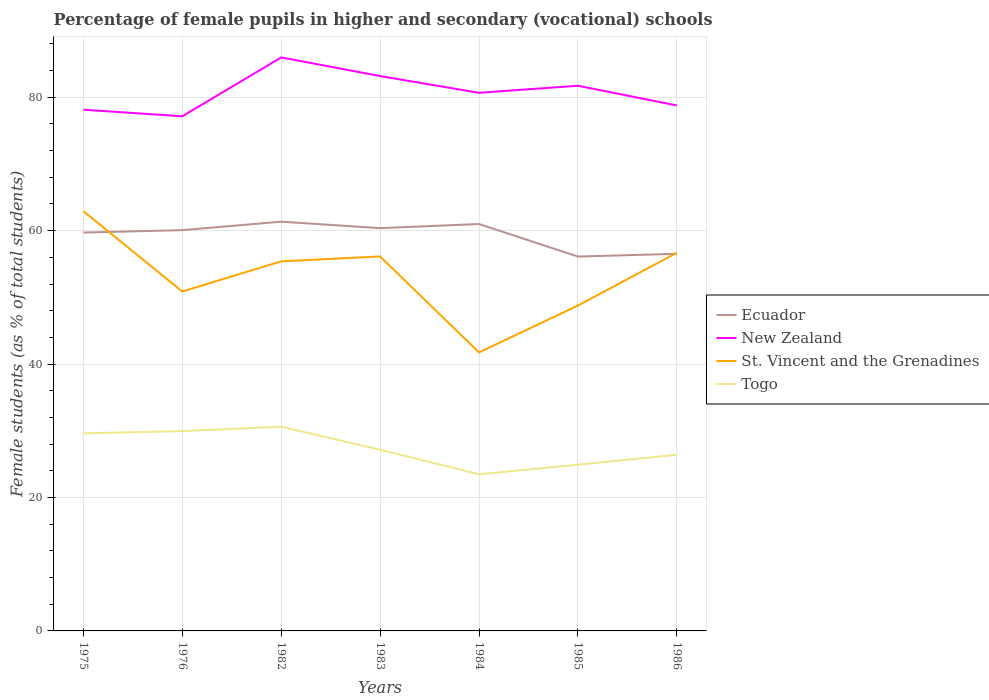Does the line corresponding to Ecuador intersect with the line corresponding to Togo?
Ensure brevity in your answer.  No. Is the number of lines equal to the number of legend labels?
Keep it short and to the point. Yes. Across all years, what is the maximum percentage of female pupils in higher and secondary schools in Togo?
Make the answer very short. 23.48. What is the total percentage of female pupils in higher and secondary schools in Ecuador in the graph?
Your answer should be compact. 5.23. What is the difference between the highest and the second highest percentage of female pupils in higher and secondary schools in Togo?
Your answer should be compact. 7.14. How many lines are there?
Your response must be concise. 4. Does the graph contain any zero values?
Ensure brevity in your answer.  No. How many legend labels are there?
Provide a succinct answer. 4. What is the title of the graph?
Provide a succinct answer. Percentage of female pupils in higher and secondary (vocational) schools. Does "Hong Kong" appear as one of the legend labels in the graph?
Keep it short and to the point. No. What is the label or title of the Y-axis?
Your answer should be compact. Female students (as % of total students). What is the Female students (as % of total students) in Ecuador in 1975?
Ensure brevity in your answer.  59.72. What is the Female students (as % of total students) in New Zealand in 1975?
Your answer should be very brief. 78.13. What is the Female students (as % of total students) of St. Vincent and the Grenadines in 1975?
Your answer should be very brief. 62.92. What is the Female students (as % of total students) of Togo in 1975?
Give a very brief answer. 29.62. What is the Female students (as % of total students) of Ecuador in 1976?
Ensure brevity in your answer.  60.08. What is the Female students (as % of total students) in New Zealand in 1976?
Ensure brevity in your answer.  77.15. What is the Female students (as % of total students) of St. Vincent and the Grenadines in 1976?
Your answer should be compact. 50.88. What is the Female students (as % of total students) of Togo in 1976?
Make the answer very short. 29.95. What is the Female students (as % of total students) of Ecuador in 1982?
Offer a very short reply. 61.35. What is the Female students (as % of total students) in New Zealand in 1982?
Your answer should be compact. 85.97. What is the Female students (as % of total students) in St. Vincent and the Grenadines in 1982?
Keep it short and to the point. 55.4. What is the Female students (as % of total students) of Togo in 1982?
Your response must be concise. 30.61. What is the Female students (as % of total students) of Ecuador in 1983?
Provide a succinct answer. 60.38. What is the Female students (as % of total students) in New Zealand in 1983?
Keep it short and to the point. 83.17. What is the Female students (as % of total students) in St. Vincent and the Grenadines in 1983?
Ensure brevity in your answer.  56.13. What is the Female students (as % of total students) in Togo in 1983?
Your answer should be very brief. 27.16. What is the Female students (as % of total students) in Ecuador in 1984?
Keep it short and to the point. 61. What is the Female students (as % of total students) of New Zealand in 1984?
Provide a short and direct response. 80.66. What is the Female students (as % of total students) in St. Vincent and the Grenadines in 1984?
Provide a short and direct response. 41.75. What is the Female students (as % of total students) in Togo in 1984?
Provide a short and direct response. 23.48. What is the Female students (as % of total students) in Ecuador in 1985?
Your response must be concise. 56.12. What is the Female students (as % of total students) in New Zealand in 1985?
Offer a very short reply. 81.72. What is the Female students (as % of total students) in St. Vincent and the Grenadines in 1985?
Offer a terse response. 48.77. What is the Female students (as % of total students) of Togo in 1985?
Your response must be concise. 24.92. What is the Female students (as % of total students) in Ecuador in 1986?
Provide a succinct answer. 56.53. What is the Female students (as % of total students) of New Zealand in 1986?
Your answer should be compact. 78.77. What is the Female students (as % of total students) in St. Vincent and the Grenadines in 1986?
Provide a short and direct response. 56.68. What is the Female students (as % of total students) of Togo in 1986?
Make the answer very short. 26.4. Across all years, what is the maximum Female students (as % of total students) in Ecuador?
Keep it short and to the point. 61.35. Across all years, what is the maximum Female students (as % of total students) of New Zealand?
Provide a short and direct response. 85.97. Across all years, what is the maximum Female students (as % of total students) in St. Vincent and the Grenadines?
Give a very brief answer. 62.92. Across all years, what is the maximum Female students (as % of total students) in Togo?
Ensure brevity in your answer.  30.61. Across all years, what is the minimum Female students (as % of total students) in Ecuador?
Your answer should be very brief. 56.12. Across all years, what is the minimum Female students (as % of total students) of New Zealand?
Make the answer very short. 77.15. Across all years, what is the minimum Female students (as % of total students) of St. Vincent and the Grenadines?
Offer a terse response. 41.75. Across all years, what is the minimum Female students (as % of total students) in Togo?
Ensure brevity in your answer.  23.48. What is the total Female students (as % of total students) in Ecuador in the graph?
Your answer should be very brief. 415.16. What is the total Female students (as % of total students) in New Zealand in the graph?
Your answer should be very brief. 565.57. What is the total Female students (as % of total students) of St. Vincent and the Grenadines in the graph?
Offer a terse response. 372.53. What is the total Female students (as % of total students) in Togo in the graph?
Make the answer very short. 192.14. What is the difference between the Female students (as % of total students) of Ecuador in 1975 and that in 1976?
Provide a short and direct response. -0.36. What is the difference between the Female students (as % of total students) in New Zealand in 1975 and that in 1976?
Offer a very short reply. 0.99. What is the difference between the Female students (as % of total students) of St. Vincent and the Grenadines in 1975 and that in 1976?
Provide a succinct answer. 12.04. What is the difference between the Female students (as % of total students) of Togo in 1975 and that in 1976?
Keep it short and to the point. -0.33. What is the difference between the Female students (as % of total students) in Ecuador in 1975 and that in 1982?
Provide a short and direct response. -1.63. What is the difference between the Female students (as % of total students) of New Zealand in 1975 and that in 1982?
Provide a succinct answer. -7.84. What is the difference between the Female students (as % of total students) of St. Vincent and the Grenadines in 1975 and that in 1982?
Your answer should be very brief. 7.52. What is the difference between the Female students (as % of total students) of Togo in 1975 and that in 1982?
Your answer should be compact. -1. What is the difference between the Female students (as % of total students) of Ecuador in 1975 and that in 1983?
Your answer should be very brief. -0.66. What is the difference between the Female students (as % of total students) in New Zealand in 1975 and that in 1983?
Provide a short and direct response. -5.04. What is the difference between the Female students (as % of total students) of St. Vincent and the Grenadines in 1975 and that in 1983?
Your answer should be very brief. 6.78. What is the difference between the Female students (as % of total students) in Togo in 1975 and that in 1983?
Your answer should be compact. 2.46. What is the difference between the Female students (as % of total students) in Ecuador in 1975 and that in 1984?
Your answer should be very brief. -1.28. What is the difference between the Female students (as % of total students) in New Zealand in 1975 and that in 1984?
Offer a very short reply. -2.53. What is the difference between the Female students (as % of total students) in St. Vincent and the Grenadines in 1975 and that in 1984?
Your answer should be compact. 21.17. What is the difference between the Female students (as % of total students) of Togo in 1975 and that in 1984?
Your answer should be compact. 6.14. What is the difference between the Female students (as % of total students) in Ecuador in 1975 and that in 1985?
Your answer should be very brief. 3.6. What is the difference between the Female students (as % of total students) of New Zealand in 1975 and that in 1985?
Give a very brief answer. -3.59. What is the difference between the Female students (as % of total students) of St. Vincent and the Grenadines in 1975 and that in 1985?
Provide a succinct answer. 14.15. What is the difference between the Female students (as % of total students) in Togo in 1975 and that in 1985?
Give a very brief answer. 4.7. What is the difference between the Female students (as % of total students) of Ecuador in 1975 and that in 1986?
Ensure brevity in your answer.  3.19. What is the difference between the Female students (as % of total students) in New Zealand in 1975 and that in 1986?
Provide a short and direct response. -0.64. What is the difference between the Female students (as % of total students) of St. Vincent and the Grenadines in 1975 and that in 1986?
Give a very brief answer. 6.24. What is the difference between the Female students (as % of total students) in Togo in 1975 and that in 1986?
Provide a succinct answer. 3.22. What is the difference between the Female students (as % of total students) of Ecuador in 1976 and that in 1982?
Your answer should be compact. -1.27. What is the difference between the Female students (as % of total students) in New Zealand in 1976 and that in 1982?
Give a very brief answer. -8.82. What is the difference between the Female students (as % of total students) of St. Vincent and the Grenadines in 1976 and that in 1982?
Your response must be concise. -4.52. What is the difference between the Female students (as % of total students) of Togo in 1976 and that in 1982?
Make the answer very short. -0.66. What is the difference between the Female students (as % of total students) of Ecuador in 1976 and that in 1983?
Offer a very short reply. -0.3. What is the difference between the Female students (as % of total students) of New Zealand in 1976 and that in 1983?
Offer a terse response. -6.03. What is the difference between the Female students (as % of total students) of St. Vincent and the Grenadines in 1976 and that in 1983?
Keep it short and to the point. -5.26. What is the difference between the Female students (as % of total students) in Togo in 1976 and that in 1983?
Provide a short and direct response. 2.79. What is the difference between the Female students (as % of total students) of Ecuador in 1976 and that in 1984?
Your response must be concise. -0.92. What is the difference between the Female students (as % of total students) of New Zealand in 1976 and that in 1984?
Ensure brevity in your answer.  -3.52. What is the difference between the Female students (as % of total students) in St. Vincent and the Grenadines in 1976 and that in 1984?
Provide a short and direct response. 9.13. What is the difference between the Female students (as % of total students) of Togo in 1976 and that in 1984?
Provide a short and direct response. 6.47. What is the difference between the Female students (as % of total students) of Ecuador in 1976 and that in 1985?
Your response must be concise. 3.96. What is the difference between the Female students (as % of total students) of New Zealand in 1976 and that in 1985?
Offer a terse response. -4.58. What is the difference between the Female students (as % of total students) of St. Vincent and the Grenadines in 1976 and that in 1985?
Make the answer very short. 2.11. What is the difference between the Female students (as % of total students) of Togo in 1976 and that in 1985?
Ensure brevity in your answer.  5.03. What is the difference between the Female students (as % of total students) of Ecuador in 1976 and that in 1986?
Ensure brevity in your answer.  3.55. What is the difference between the Female students (as % of total students) in New Zealand in 1976 and that in 1986?
Your response must be concise. -1.62. What is the difference between the Female students (as % of total students) of St. Vincent and the Grenadines in 1976 and that in 1986?
Ensure brevity in your answer.  -5.8. What is the difference between the Female students (as % of total students) in Togo in 1976 and that in 1986?
Your answer should be very brief. 3.55. What is the difference between the Female students (as % of total students) in Ecuador in 1982 and that in 1983?
Give a very brief answer. 0.97. What is the difference between the Female students (as % of total students) in New Zealand in 1982 and that in 1983?
Ensure brevity in your answer.  2.8. What is the difference between the Female students (as % of total students) of St. Vincent and the Grenadines in 1982 and that in 1983?
Your answer should be compact. -0.73. What is the difference between the Female students (as % of total students) in Togo in 1982 and that in 1983?
Make the answer very short. 3.46. What is the difference between the Female students (as % of total students) in Ecuador in 1982 and that in 1984?
Offer a terse response. 0.35. What is the difference between the Female students (as % of total students) of New Zealand in 1982 and that in 1984?
Your response must be concise. 5.31. What is the difference between the Female students (as % of total students) of St. Vincent and the Grenadines in 1982 and that in 1984?
Your answer should be very brief. 13.65. What is the difference between the Female students (as % of total students) in Togo in 1982 and that in 1984?
Your response must be concise. 7.14. What is the difference between the Female students (as % of total students) of Ecuador in 1982 and that in 1985?
Ensure brevity in your answer.  5.23. What is the difference between the Female students (as % of total students) in New Zealand in 1982 and that in 1985?
Make the answer very short. 4.25. What is the difference between the Female students (as % of total students) of St. Vincent and the Grenadines in 1982 and that in 1985?
Provide a short and direct response. 6.63. What is the difference between the Female students (as % of total students) in Togo in 1982 and that in 1985?
Offer a terse response. 5.7. What is the difference between the Female students (as % of total students) of Ecuador in 1982 and that in 1986?
Keep it short and to the point. 4.82. What is the difference between the Female students (as % of total students) in New Zealand in 1982 and that in 1986?
Offer a very short reply. 7.2. What is the difference between the Female students (as % of total students) in St. Vincent and the Grenadines in 1982 and that in 1986?
Ensure brevity in your answer.  -1.28. What is the difference between the Female students (as % of total students) of Togo in 1982 and that in 1986?
Give a very brief answer. 4.21. What is the difference between the Female students (as % of total students) of Ecuador in 1983 and that in 1984?
Keep it short and to the point. -0.62. What is the difference between the Female students (as % of total students) of New Zealand in 1983 and that in 1984?
Offer a very short reply. 2.51. What is the difference between the Female students (as % of total students) of St. Vincent and the Grenadines in 1983 and that in 1984?
Your answer should be compact. 14.39. What is the difference between the Female students (as % of total students) of Togo in 1983 and that in 1984?
Keep it short and to the point. 3.68. What is the difference between the Female students (as % of total students) in Ecuador in 1983 and that in 1985?
Offer a terse response. 4.26. What is the difference between the Female students (as % of total students) of New Zealand in 1983 and that in 1985?
Provide a short and direct response. 1.45. What is the difference between the Female students (as % of total students) of St. Vincent and the Grenadines in 1983 and that in 1985?
Your answer should be very brief. 7.36. What is the difference between the Female students (as % of total students) in Togo in 1983 and that in 1985?
Your response must be concise. 2.24. What is the difference between the Female students (as % of total students) of Ecuador in 1983 and that in 1986?
Your response must be concise. 3.85. What is the difference between the Female students (as % of total students) in New Zealand in 1983 and that in 1986?
Give a very brief answer. 4.4. What is the difference between the Female students (as % of total students) of St. Vincent and the Grenadines in 1983 and that in 1986?
Your answer should be very brief. -0.55. What is the difference between the Female students (as % of total students) in Togo in 1983 and that in 1986?
Offer a terse response. 0.76. What is the difference between the Female students (as % of total students) of Ecuador in 1984 and that in 1985?
Make the answer very short. 4.88. What is the difference between the Female students (as % of total students) in New Zealand in 1984 and that in 1985?
Your answer should be very brief. -1.06. What is the difference between the Female students (as % of total students) of St. Vincent and the Grenadines in 1984 and that in 1985?
Keep it short and to the point. -7.02. What is the difference between the Female students (as % of total students) in Togo in 1984 and that in 1985?
Provide a succinct answer. -1.44. What is the difference between the Female students (as % of total students) in Ecuador in 1984 and that in 1986?
Your answer should be very brief. 4.47. What is the difference between the Female students (as % of total students) of New Zealand in 1984 and that in 1986?
Give a very brief answer. 1.89. What is the difference between the Female students (as % of total students) of St. Vincent and the Grenadines in 1984 and that in 1986?
Your answer should be compact. -14.93. What is the difference between the Female students (as % of total students) in Togo in 1984 and that in 1986?
Provide a short and direct response. -2.92. What is the difference between the Female students (as % of total students) in Ecuador in 1985 and that in 1986?
Keep it short and to the point. -0.41. What is the difference between the Female students (as % of total students) in New Zealand in 1985 and that in 1986?
Offer a very short reply. 2.95. What is the difference between the Female students (as % of total students) of St. Vincent and the Grenadines in 1985 and that in 1986?
Provide a short and direct response. -7.91. What is the difference between the Female students (as % of total students) of Togo in 1985 and that in 1986?
Make the answer very short. -1.48. What is the difference between the Female students (as % of total students) of Ecuador in 1975 and the Female students (as % of total students) of New Zealand in 1976?
Provide a short and direct response. -17.43. What is the difference between the Female students (as % of total students) in Ecuador in 1975 and the Female students (as % of total students) in St. Vincent and the Grenadines in 1976?
Your answer should be compact. 8.84. What is the difference between the Female students (as % of total students) of Ecuador in 1975 and the Female students (as % of total students) of Togo in 1976?
Provide a short and direct response. 29.77. What is the difference between the Female students (as % of total students) of New Zealand in 1975 and the Female students (as % of total students) of St. Vincent and the Grenadines in 1976?
Your answer should be very brief. 27.25. What is the difference between the Female students (as % of total students) of New Zealand in 1975 and the Female students (as % of total students) of Togo in 1976?
Your answer should be very brief. 48.18. What is the difference between the Female students (as % of total students) of St. Vincent and the Grenadines in 1975 and the Female students (as % of total students) of Togo in 1976?
Keep it short and to the point. 32.97. What is the difference between the Female students (as % of total students) in Ecuador in 1975 and the Female students (as % of total students) in New Zealand in 1982?
Give a very brief answer. -26.25. What is the difference between the Female students (as % of total students) of Ecuador in 1975 and the Female students (as % of total students) of St. Vincent and the Grenadines in 1982?
Your answer should be compact. 4.31. What is the difference between the Female students (as % of total students) in Ecuador in 1975 and the Female students (as % of total students) in Togo in 1982?
Give a very brief answer. 29.1. What is the difference between the Female students (as % of total students) in New Zealand in 1975 and the Female students (as % of total students) in St. Vincent and the Grenadines in 1982?
Your answer should be very brief. 22.73. What is the difference between the Female students (as % of total students) of New Zealand in 1975 and the Female students (as % of total students) of Togo in 1982?
Your response must be concise. 47.52. What is the difference between the Female students (as % of total students) of St. Vincent and the Grenadines in 1975 and the Female students (as % of total students) of Togo in 1982?
Keep it short and to the point. 32.3. What is the difference between the Female students (as % of total students) in Ecuador in 1975 and the Female students (as % of total students) in New Zealand in 1983?
Offer a very short reply. -23.46. What is the difference between the Female students (as % of total students) in Ecuador in 1975 and the Female students (as % of total students) in St. Vincent and the Grenadines in 1983?
Your response must be concise. 3.58. What is the difference between the Female students (as % of total students) of Ecuador in 1975 and the Female students (as % of total students) of Togo in 1983?
Your answer should be very brief. 32.56. What is the difference between the Female students (as % of total students) in New Zealand in 1975 and the Female students (as % of total students) in St. Vincent and the Grenadines in 1983?
Your response must be concise. 22. What is the difference between the Female students (as % of total students) in New Zealand in 1975 and the Female students (as % of total students) in Togo in 1983?
Your answer should be very brief. 50.97. What is the difference between the Female students (as % of total students) of St. Vincent and the Grenadines in 1975 and the Female students (as % of total students) of Togo in 1983?
Keep it short and to the point. 35.76. What is the difference between the Female students (as % of total students) of Ecuador in 1975 and the Female students (as % of total students) of New Zealand in 1984?
Your answer should be compact. -20.95. What is the difference between the Female students (as % of total students) of Ecuador in 1975 and the Female students (as % of total students) of St. Vincent and the Grenadines in 1984?
Keep it short and to the point. 17.97. What is the difference between the Female students (as % of total students) of Ecuador in 1975 and the Female students (as % of total students) of Togo in 1984?
Provide a succinct answer. 36.24. What is the difference between the Female students (as % of total students) of New Zealand in 1975 and the Female students (as % of total students) of St. Vincent and the Grenadines in 1984?
Keep it short and to the point. 36.38. What is the difference between the Female students (as % of total students) of New Zealand in 1975 and the Female students (as % of total students) of Togo in 1984?
Offer a terse response. 54.65. What is the difference between the Female students (as % of total students) in St. Vincent and the Grenadines in 1975 and the Female students (as % of total students) in Togo in 1984?
Give a very brief answer. 39.44. What is the difference between the Female students (as % of total students) of Ecuador in 1975 and the Female students (as % of total students) of New Zealand in 1985?
Make the answer very short. -22.01. What is the difference between the Female students (as % of total students) of Ecuador in 1975 and the Female students (as % of total students) of St. Vincent and the Grenadines in 1985?
Your answer should be very brief. 10.94. What is the difference between the Female students (as % of total students) of Ecuador in 1975 and the Female students (as % of total students) of Togo in 1985?
Ensure brevity in your answer.  34.8. What is the difference between the Female students (as % of total students) in New Zealand in 1975 and the Female students (as % of total students) in St. Vincent and the Grenadines in 1985?
Your answer should be very brief. 29.36. What is the difference between the Female students (as % of total students) of New Zealand in 1975 and the Female students (as % of total students) of Togo in 1985?
Ensure brevity in your answer.  53.21. What is the difference between the Female students (as % of total students) of St. Vincent and the Grenadines in 1975 and the Female students (as % of total students) of Togo in 1985?
Your answer should be compact. 38. What is the difference between the Female students (as % of total students) in Ecuador in 1975 and the Female students (as % of total students) in New Zealand in 1986?
Provide a succinct answer. -19.05. What is the difference between the Female students (as % of total students) of Ecuador in 1975 and the Female students (as % of total students) of St. Vincent and the Grenadines in 1986?
Your response must be concise. 3.04. What is the difference between the Female students (as % of total students) of Ecuador in 1975 and the Female students (as % of total students) of Togo in 1986?
Your answer should be very brief. 33.31. What is the difference between the Female students (as % of total students) in New Zealand in 1975 and the Female students (as % of total students) in St. Vincent and the Grenadines in 1986?
Keep it short and to the point. 21.45. What is the difference between the Female students (as % of total students) of New Zealand in 1975 and the Female students (as % of total students) of Togo in 1986?
Your response must be concise. 51.73. What is the difference between the Female students (as % of total students) of St. Vincent and the Grenadines in 1975 and the Female students (as % of total students) of Togo in 1986?
Make the answer very short. 36.52. What is the difference between the Female students (as % of total students) of Ecuador in 1976 and the Female students (as % of total students) of New Zealand in 1982?
Provide a short and direct response. -25.89. What is the difference between the Female students (as % of total students) of Ecuador in 1976 and the Female students (as % of total students) of St. Vincent and the Grenadines in 1982?
Provide a short and direct response. 4.67. What is the difference between the Female students (as % of total students) of Ecuador in 1976 and the Female students (as % of total students) of Togo in 1982?
Provide a succinct answer. 29.46. What is the difference between the Female students (as % of total students) in New Zealand in 1976 and the Female students (as % of total students) in St. Vincent and the Grenadines in 1982?
Your answer should be very brief. 21.75. What is the difference between the Female students (as % of total students) in New Zealand in 1976 and the Female students (as % of total students) in Togo in 1982?
Your answer should be compact. 46.53. What is the difference between the Female students (as % of total students) in St. Vincent and the Grenadines in 1976 and the Female students (as % of total students) in Togo in 1982?
Your answer should be compact. 20.26. What is the difference between the Female students (as % of total students) of Ecuador in 1976 and the Female students (as % of total students) of New Zealand in 1983?
Your answer should be very brief. -23.1. What is the difference between the Female students (as % of total students) of Ecuador in 1976 and the Female students (as % of total students) of St. Vincent and the Grenadines in 1983?
Your answer should be compact. 3.94. What is the difference between the Female students (as % of total students) of Ecuador in 1976 and the Female students (as % of total students) of Togo in 1983?
Offer a terse response. 32.92. What is the difference between the Female students (as % of total students) in New Zealand in 1976 and the Female students (as % of total students) in St. Vincent and the Grenadines in 1983?
Make the answer very short. 21.01. What is the difference between the Female students (as % of total students) of New Zealand in 1976 and the Female students (as % of total students) of Togo in 1983?
Your response must be concise. 49.99. What is the difference between the Female students (as % of total students) in St. Vincent and the Grenadines in 1976 and the Female students (as % of total students) in Togo in 1983?
Offer a terse response. 23.72. What is the difference between the Female students (as % of total students) of Ecuador in 1976 and the Female students (as % of total students) of New Zealand in 1984?
Provide a short and direct response. -20.59. What is the difference between the Female students (as % of total students) in Ecuador in 1976 and the Female students (as % of total students) in St. Vincent and the Grenadines in 1984?
Offer a terse response. 18.33. What is the difference between the Female students (as % of total students) in Ecuador in 1976 and the Female students (as % of total students) in Togo in 1984?
Your answer should be very brief. 36.6. What is the difference between the Female students (as % of total students) in New Zealand in 1976 and the Female students (as % of total students) in St. Vincent and the Grenadines in 1984?
Your response must be concise. 35.4. What is the difference between the Female students (as % of total students) of New Zealand in 1976 and the Female students (as % of total students) of Togo in 1984?
Your answer should be very brief. 53.67. What is the difference between the Female students (as % of total students) of St. Vincent and the Grenadines in 1976 and the Female students (as % of total students) of Togo in 1984?
Offer a terse response. 27.4. What is the difference between the Female students (as % of total students) in Ecuador in 1976 and the Female students (as % of total students) in New Zealand in 1985?
Offer a terse response. -21.65. What is the difference between the Female students (as % of total students) in Ecuador in 1976 and the Female students (as % of total students) in St. Vincent and the Grenadines in 1985?
Your response must be concise. 11.3. What is the difference between the Female students (as % of total students) in Ecuador in 1976 and the Female students (as % of total students) in Togo in 1985?
Provide a short and direct response. 35.16. What is the difference between the Female students (as % of total students) in New Zealand in 1976 and the Female students (as % of total students) in St. Vincent and the Grenadines in 1985?
Give a very brief answer. 28.37. What is the difference between the Female students (as % of total students) in New Zealand in 1976 and the Female students (as % of total students) in Togo in 1985?
Your response must be concise. 52.23. What is the difference between the Female students (as % of total students) of St. Vincent and the Grenadines in 1976 and the Female students (as % of total students) of Togo in 1985?
Ensure brevity in your answer.  25.96. What is the difference between the Female students (as % of total students) in Ecuador in 1976 and the Female students (as % of total students) in New Zealand in 1986?
Your answer should be compact. -18.69. What is the difference between the Female students (as % of total students) of Ecuador in 1976 and the Female students (as % of total students) of St. Vincent and the Grenadines in 1986?
Offer a terse response. 3.4. What is the difference between the Female students (as % of total students) in Ecuador in 1976 and the Female students (as % of total students) in Togo in 1986?
Provide a short and direct response. 33.67. What is the difference between the Female students (as % of total students) of New Zealand in 1976 and the Female students (as % of total students) of St. Vincent and the Grenadines in 1986?
Give a very brief answer. 20.47. What is the difference between the Female students (as % of total students) in New Zealand in 1976 and the Female students (as % of total students) in Togo in 1986?
Offer a terse response. 50.74. What is the difference between the Female students (as % of total students) in St. Vincent and the Grenadines in 1976 and the Female students (as % of total students) in Togo in 1986?
Provide a succinct answer. 24.48. What is the difference between the Female students (as % of total students) in Ecuador in 1982 and the Female students (as % of total students) in New Zealand in 1983?
Keep it short and to the point. -21.83. What is the difference between the Female students (as % of total students) of Ecuador in 1982 and the Female students (as % of total students) of St. Vincent and the Grenadines in 1983?
Give a very brief answer. 5.21. What is the difference between the Female students (as % of total students) of Ecuador in 1982 and the Female students (as % of total students) of Togo in 1983?
Your answer should be very brief. 34.19. What is the difference between the Female students (as % of total students) of New Zealand in 1982 and the Female students (as % of total students) of St. Vincent and the Grenadines in 1983?
Offer a very short reply. 29.83. What is the difference between the Female students (as % of total students) in New Zealand in 1982 and the Female students (as % of total students) in Togo in 1983?
Ensure brevity in your answer.  58.81. What is the difference between the Female students (as % of total students) in St. Vincent and the Grenadines in 1982 and the Female students (as % of total students) in Togo in 1983?
Give a very brief answer. 28.24. What is the difference between the Female students (as % of total students) in Ecuador in 1982 and the Female students (as % of total students) in New Zealand in 1984?
Make the answer very short. -19.32. What is the difference between the Female students (as % of total students) in Ecuador in 1982 and the Female students (as % of total students) in St. Vincent and the Grenadines in 1984?
Offer a terse response. 19.6. What is the difference between the Female students (as % of total students) in Ecuador in 1982 and the Female students (as % of total students) in Togo in 1984?
Your response must be concise. 37.87. What is the difference between the Female students (as % of total students) in New Zealand in 1982 and the Female students (as % of total students) in St. Vincent and the Grenadines in 1984?
Ensure brevity in your answer.  44.22. What is the difference between the Female students (as % of total students) of New Zealand in 1982 and the Female students (as % of total students) of Togo in 1984?
Your answer should be compact. 62.49. What is the difference between the Female students (as % of total students) of St. Vincent and the Grenadines in 1982 and the Female students (as % of total students) of Togo in 1984?
Give a very brief answer. 31.92. What is the difference between the Female students (as % of total students) of Ecuador in 1982 and the Female students (as % of total students) of New Zealand in 1985?
Keep it short and to the point. -20.38. What is the difference between the Female students (as % of total students) in Ecuador in 1982 and the Female students (as % of total students) in St. Vincent and the Grenadines in 1985?
Keep it short and to the point. 12.57. What is the difference between the Female students (as % of total students) of Ecuador in 1982 and the Female students (as % of total students) of Togo in 1985?
Give a very brief answer. 36.43. What is the difference between the Female students (as % of total students) of New Zealand in 1982 and the Female students (as % of total students) of St. Vincent and the Grenadines in 1985?
Your answer should be compact. 37.2. What is the difference between the Female students (as % of total students) of New Zealand in 1982 and the Female students (as % of total students) of Togo in 1985?
Ensure brevity in your answer.  61.05. What is the difference between the Female students (as % of total students) in St. Vincent and the Grenadines in 1982 and the Female students (as % of total students) in Togo in 1985?
Give a very brief answer. 30.48. What is the difference between the Female students (as % of total students) in Ecuador in 1982 and the Female students (as % of total students) in New Zealand in 1986?
Offer a very short reply. -17.42. What is the difference between the Female students (as % of total students) in Ecuador in 1982 and the Female students (as % of total students) in St. Vincent and the Grenadines in 1986?
Provide a short and direct response. 4.67. What is the difference between the Female students (as % of total students) of Ecuador in 1982 and the Female students (as % of total students) of Togo in 1986?
Offer a terse response. 34.94. What is the difference between the Female students (as % of total students) in New Zealand in 1982 and the Female students (as % of total students) in St. Vincent and the Grenadines in 1986?
Provide a succinct answer. 29.29. What is the difference between the Female students (as % of total students) in New Zealand in 1982 and the Female students (as % of total students) in Togo in 1986?
Your response must be concise. 59.57. What is the difference between the Female students (as % of total students) of St. Vincent and the Grenadines in 1982 and the Female students (as % of total students) of Togo in 1986?
Offer a very short reply. 29. What is the difference between the Female students (as % of total students) in Ecuador in 1983 and the Female students (as % of total students) in New Zealand in 1984?
Provide a succinct answer. -20.29. What is the difference between the Female students (as % of total students) of Ecuador in 1983 and the Female students (as % of total students) of St. Vincent and the Grenadines in 1984?
Ensure brevity in your answer.  18.63. What is the difference between the Female students (as % of total students) of Ecuador in 1983 and the Female students (as % of total students) of Togo in 1984?
Your answer should be very brief. 36.9. What is the difference between the Female students (as % of total students) of New Zealand in 1983 and the Female students (as % of total students) of St. Vincent and the Grenadines in 1984?
Provide a succinct answer. 41.42. What is the difference between the Female students (as % of total students) in New Zealand in 1983 and the Female students (as % of total students) in Togo in 1984?
Give a very brief answer. 59.69. What is the difference between the Female students (as % of total students) in St. Vincent and the Grenadines in 1983 and the Female students (as % of total students) in Togo in 1984?
Your response must be concise. 32.66. What is the difference between the Female students (as % of total students) in Ecuador in 1983 and the Female students (as % of total students) in New Zealand in 1985?
Ensure brevity in your answer.  -21.35. What is the difference between the Female students (as % of total students) of Ecuador in 1983 and the Female students (as % of total students) of St. Vincent and the Grenadines in 1985?
Make the answer very short. 11.6. What is the difference between the Female students (as % of total students) in Ecuador in 1983 and the Female students (as % of total students) in Togo in 1985?
Give a very brief answer. 35.46. What is the difference between the Female students (as % of total students) of New Zealand in 1983 and the Female students (as % of total students) of St. Vincent and the Grenadines in 1985?
Give a very brief answer. 34.4. What is the difference between the Female students (as % of total students) in New Zealand in 1983 and the Female students (as % of total students) in Togo in 1985?
Ensure brevity in your answer.  58.25. What is the difference between the Female students (as % of total students) of St. Vincent and the Grenadines in 1983 and the Female students (as % of total students) of Togo in 1985?
Give a very brief answer. 31.22. What is the difference between the Female students (as % of total students) of Ecuador in 1983 and the Female students (as % of total students) of New Zealand in 1986?
Keep it short and to the point. -18.39. What is the difference between the Female students (as % of total students) of Ecuador in 1983 and the Female students (as % of total students) of St. Vincent and the Grenadines in 1986?
Provide a short and direct response. 3.7. What is the difference between the Female students (as % of total students) in Ecuador in 1983 and the Female students (as % of total students) in Togo in 1986?
Provide a succinct answer. 33.97. What is the difference between the Female students (as % of total students) in New Zealand in 1983 and the Female students (as % of total students) in St. Vincent and the Grenadines in 1986?
Provide a short and direct response. 26.49. What is the difference between the Female students (as % of total students) of New Zealand in 1983 and the Female students (as % of total students) of Togo in 1986?
Give a very brief answer. 56.77. What is the difference between the Female students (as % of total students) in St. Vincent and the Grenadines in 1983 and the Female students (as % of total students) in Togo in 1986?
Your answer should be very brief. 29.73. What is the difference between the Female students (as % of total students) of Ecuador in 1984 and the Female students (as % of total students) of New Zealand in 1985?
Your answer should be compact. -20.73. What is the difference between the Female students (as % of total students) of Ecuador in 1984 and the Female students (as % of total students) of St. Vincent and the Grenadines in 1985?
Provide a short and direct response. 12.22. What is the difference between the Female students (as % of total students) of Ecuador in 1984 and the Female students (as % of total students) of Togo in 1985?
Provide a succinct answer. 36.08. What is the difference between the Female students (as % of total students) of New Zealand in 1984 and the Female students (as % of total students) of St. Vincent and the Grenadines in 1985?
Keep it short and to the point. 31.89. What is the difference between the Female students (as % of total students) in New Zealand in 1984 and the Female students (as % of total students) in Togo in 1985?
Make the answer very short. 55.75. What is the difference between the Female students (as % of total students) of St. Vincent and the Grenadines in 1984 and the Female students (as % of total students) of Togo in 1985?
Provide a short and direct response. 16.83. What is the difference between the Female students (as % of total students) of Ecuador in 1984 and the Female students (as % of total students) of New Zealand in 1986?
Your answer should be very brief. -17.77. What is the difference between the Female students (as % of total students) in Ecuador in 1984 and the Female students (as % of total students) in St. Vincent and the Grenadines in 1986?
Make the answer very short. 4.32. What is the difference between the Female students (as % of total students) of Ecuador in 1984 and the Female students (as % of total students) of Togo in 1986?
Ensure brevity in your answer.  34.59. What is the difference between the Female students (as % of total students) of New Zealand in 1984 and the Female students (as % of total students) of St. Vincent and the Grenadines in 1986?
Keep it short and to the point. 23.98. What is the difference between the Female students (as % of total students) of New Zealand in 1984 and the Female students (as % of total students) of Togo in 1986?
Keep it short and to the point. 54.26. What is the difference between the Female students (as % of total students) in St. Vincent and the Grenadines in 1984 and the Female students (as % of total students) in Togo in 1986?
Your answer should be very brief. 15.35. What is the difference between the Female students (as % of total students) of Ecuador in 1985 and the Female students (as % of total students) of New Zealand in 1986?
Give a very brief answer. -22.65. What is the difference between the Female students (as % of total students) in Ecuador in 1985 and the Female students (as % of total students) in St. Vincent and the Grenadines in 1986?
Offer a very short reply. -0.56. What is the difference between the Female students (as % of total students) in Ecuador in 1985 and the Female students (as % of total students) in Togo in 1986?
Keep it short and to the point. 29.72. What is the difference between the Female students (as % of total students) of New Zealand in 1985 and the Female students (as % of total students) of St. Vincent and the Grenadines in 1986?
Your answer should be very brief. 25.04. What is the difference between the Female students (as % of total students) of New Zealand in 1985 and the Female students (as % of total students) of Togo in 1986?
Ensure brevity in your answer.  55.32. What is the difference between the Female students (as % of total students) in St. Vincent and the Grenadines in 1985 and the Female students (as % of total students) in Togo in 1986?
Make the answer very short. 22.37. What is the average Female students (as % of total students) of Ecuador per year?
Make the answer very short. 59.31. What is the average Female students (as % of total students) in New Zealand per year?
Your answer should be compact. 80.8. What is the average Female students (as % of total students) of St. Vincent and the Grenadines per year?
Ensure brevity in your answer.  53.22. What is the average Female students (as % of total students) of Togo per year?
Offer a terse response. 27.45. In the year 1975, what is the difference between the Female students (as % of total students) in Ecuador and Female students (as % of total students) in New Zealand?
Give a very brief answer. -18.42. In the year 1975, what is the difference between the Female students (as % of total students) in Ecuador and Female students (as % of total students) in St. Vincent and the Grenadines?
Your answer should be very brief. -3.2. In the year 1975, what is the difference between the Female students (as % of total students) in Ecuador and Female students (as % of total students) in Togo?
Give a very brief answer. 30.1. In the year 1975, what is the difference between the Female students (as % of total students) of New Zealand and Female students (as % of total students) of St. Vincent and the Grenadines?
Provide a short and direct response. 15.21. In the year 1975, what is the difference between the Female students (as % of total students) of New Zealand and Female students (as % of total students) of Togo?
Your answer should be very brief. 48.51. In the year 1975, what is the difference between the Female students (as % of total students) in St. Vincent and the Grenadines and Female students (as % of total students) in Togo?
Your answer should be very brief. 33.3. In the year 1976, what is the difference between the Female students (as % of total students) in Ecuador and Female students (as % of total students) in New Zealand?
Make the answer very short. -17.07. In the year 1976, what is the difference between the Female students (as % of total students) of Ecuador and Female students (as % of total students) of St. Vincent and the Grenadines?
Keep it short and to the point. 9.2. In the year 1976, what is the difference between the Female students (as % of total students) in Ecuador and Female students (as % of total students) in Togo?
Provide a succinct answer. 30.13. In the year 1976, what is the difference between the Female students (as % of total students) of New Zealand and Female students (as % of total students) of St. Vincent and the Grenadines?
Keep it short and to the point. 26.27. In the year 1976, what is the difference between the Female students (as % of total students) in New Zealand and Female students (as % of total students) in Togo?
Ensure brevity in your answer.  47.2. In the year 1976, what is the difference between the Female students (as % of total students) in St. Vincent and the Grenadines and Female students (as % of total students) in Togo?
Offer a very short reply. 20.93. In the year 1982, what is the difference between the Female students (as % of total students) of Ecuador and Female students (as % of total students) of New Zealand?
Your answer should be compact. -24.62. In the year 1982, what is the difference between the Female students (as % of total students) of Ecuador and Female students (as % of total students) of St. Vincent and the Grenadines?
Keep it short and to the point. 5.95. In the year 1982, what is the difference between the Female students (as % of total students) in Ecuador and Female students (as % of total students) in Togo?
Provide a succinct answer. 30.73. In the year 1982, what is the difference between the Female students (as % of total students) of New Zealand and Female students (as % of total students) of St. Vincent and the Grenadines?
Your answer should be compact. 30.57. In the year 1982, what is the difference between the Female students (as % of total students) in New Zealand and Female students (as % of total students) in Togo?
Provide a succinct answer. 55.35. In the year 1982, what is the difference between the Female students (as % of total students) in St. Vincent and the Grenadines and Female students (as % of total students) in Togo?
Offer a very short reply. 24.79. In the year 1983, what is the difference between the Female students (as % of total students) of Ecuador and Female students (as % of total students) of New Zealand?
Your response must be concise. -22.8. In the year 1983, what is the difference between the Female students (as % of total students) of Ecuador and Female students (as % of total students) of St. Vincent and the Grenadines?
Keep it short and to the point. 4.24. In the year 1983, what is the difference between the Female students (as % of total students) of Ecuador and Female students (as % of total students) of Togo?
Provide a short and direct response. 33.22. In the year 1983, what is the difference between the Female students (as % of total students) of New Zealand and Female students (as % of total students) of St. Vincent and the Grenadines?
Your answer should be very brief. 27.04. In the year 1983, what is the difference between the Female students (as % of total students) in New Zealand and Female students (as % of total students) in Togo?
Give a very brief answer. 56.01. In the year 1983, what is the difference between the Female students (as % of total students) of St. Vincent and the Grenadines and Female students (as % of total students) of Togo?
Keep it short and to the point. 28.98. In the year 1984, what is the difference between the Female students (as % of total students) in Ecuador and Female students (as % of total students) in New Zealand?
Provide a short and direct response. -19.67. In the year 1984, what is the difference between the Female students (as % of total students) of Ecuador and Female students (as % of total students) of St. Vincent and the Grenadines?
Keep it short and to the point. 19.25. In the year 1984, what is the difference between the Female students (as % of total students) in Ecuador and Female students (as % of total students) in Togo?
Your answer should be very brief. 37.52. In the year 1984, what is the difference between the Female students (as % of total students) in New Zealand and Female students (as % of total students) in St. Vincent and the Grenadines?
Give a very brief answer. 38.92. In the year 1984, what is the difference between the Female students (as % of total students) in New Zealand and Female students (as % of total students) in Togo?
Your response must be concise. 57.18. In the year 1984, what is the difference between the Female students (as % of total students) in St. Vincent and the Grenadines and Female students (as % of total students) in Togo?
Offer a terse response. 18.27. In the year 1985, what is the difference between the Female students (as % of total students) of Ecuador and Female students (as % of total students) of New Zealand?
Keep it short and to the point. -25.6. In the year 1985, what is the difference between the Female students (as % of total students) in Ecuador and Female students (as % of total students) in St. Vincent and the Grenadines?
Your response must be concise. 7.35. In the year 1985, what is the difference between the Female students (as % of total students) of Ecuador and Female students (as % of total students) of Togo?
Provide a short and direct response. 31.2. In the year 1985, what is the difference between the Female students (as % of total students) in New Zealand and Female students (as % of total students) in St. Vincent and the Grenadines?
Give a very brief answer. 32.95. In the year 1985, what is the difference between the Female students (as % of total students) of New Zealand and Female students (as % of total students) of Togo?
Your answer should be very brief. 56.8. In the year 1985, what is the difference between the Female students (as % of total students) of St. Vincent and the Grenadines and Female students (as % of total students) of Togo?
Your response must be concise. 23.85. In the year 1986, what is the difference between the Female students (as % of total students) in Ecuador and Female students (as % of total students) in New Zealand?
Give a very brief answer. -22.24. In the year 1986, what is the difference between the Female students (as % of total students) of Ecuador and Female students (as % of total students) of St. Vincent and the Grenadines?
Offer a terse response. -0.15. In the year 1986, what is the difference between the Female students (as % of total students) of Ecuador and Female students (as % of total students) of Togo?
Provide a short and direct response. 30.13. In the year 1986, what is the difference between the Female students (as % of total students) in New Zealand and Female students (as % of total students) in St. Vincent and the Grenadines?
Make the answer very short. 22.09. In the year 1986, what is the difference between the Female students (as % of total students) of New Zealand and Female students (as % of total students) of Togo?
Your answer should be very brief. 52.37. In the year 1986, what is the difference between the Female students (as % of total students) of St. Vincent and the Grenadines and Female students (as % of total students) of Togo?
Your response must be concise. 30.28. What is the ratio of the Female students (as % of total students) of Ecuador in 1975 to that in 1976?
Your answer should be compact. 0.99. What is the ratio of the Female students (as % of total students) of New Zealand in 1975 to that in 1976?
Your answer should be compact. 1.01. What is the ratio of the Female students (as % of total students) in St. Vincent and the Grenadines in 1975 to that in 1976?
Provide a short and direct response. 1.24. What is the ratio of the Female students (as % of total students) in Togo in 1975 to that in 1976?
Offer a very short reply. 0.99. What is the ratio of the Female students (as % of total students) in Ecuador in 1975 to that in 1982?
Offer a terse response. 0.97. What is the ratio of the Female students (as % of total students) of New Zealand in 1975 to that in 1982?
Ensure brevity in your answer.  0.91. What is the ratio of the Female students (as % of total students) of St. Vincent and the Grenadines in 1975 to that in 1982?
Provide a succinct answer. 1.14. What is the ratio of the Female students (as % of total students) of Togo in 1975 to that in 1982?
Your answer should be compact. 0.97. What is the ratio of the Female students (as % of total students) in Ecuador in 1975 to that in 1983?
Your answer should be very brief. 0.99. What is the ratio of the Female students (as % of total students) in New Zealand in 1975 to that in 1983?
Provide a short and direct response. 0.94. What is the ratio of the Female students (as % of total students) in St. Vincent and the Grenadines in 1975 to that in 1983?
Offer a terse response. 1.12. What is the ratio of the Female students (as % of total students) of Togo in 1975 to that in 1983?
Your answer should be very brief. 1.09. What is the ratio of the Female students (as % of total students) of Ecuador in 1975 to that in 1984?
Your response must be concise. 0.98. What is the ratio of the Female students (as % of total students) in New Zealand in 1975 to that in 1984?
Your answer should be very brief. 0.97. What is the ratio of the Female students (as % of total students) of St. Vincent and the Grenadines in 1975 to that in 1984?
Offer a very short reply. 1.51. What is the ratio of the Female students (as % of total students) of Togo in 1975 to that in 1984?
Offer a very short reply. 1.26. What is the ratio of the Female students (as % of total students) of Ecuador in 1975 to that in 1985?
Offer a terse response. 1.06. What is the ratio of the Female students (as % of total students) of New Zealand in 1975 to that in 1985?
Provide a succinct answer. 0.96. What is the ratio of the Female students (as % of total students) of St. Vincent and the Grenadines in 1975 to that in 1985?
Your answer should be very brief. 1.29. What is the ratio of the Female students (as % of total students) of Togo in 1975 to that in 1985?
Offer a terse response. 1.19. What is the ratio of the Female students (as % of total students) in Ecuador in 1975 to that in 1986?
Give a very brief answer. 1.06. What is the ratio of the Female students (as % of total students) in New Zealand in 1975 to that in 1986?
Ensure brevity in your answer.  0.99. What is the ratio of the Female students (as % of total students) of St. Vincent and the Grenadines in 1975 to that in 1986?
Provide a succinct answer. 1.11. What is the ratio of the Female students (as % of total students) of Togo in 1975 to that in 1986?
Your answer should be very brief. 1.12. What is the ratio of the Female students (as % of total students) in Ecuador in 1976 to that in 1982?
Provide a succinct answer. 0.98. What is the ratio of the Female students (as % of total students) in New Zealand in 1976 to that in 1982?
Offer a very short reply. 0.9. What is the ratio of the Female students (as % of total students) in St. Vincent and the Grenadines in 1976 to that in 1982?
Give a very brief answer. 0.92. What is the ratio of the Female students (as % of total students) of Togo in 1976 to that in 1982?
Keep it short and to the point. 0.98. What is the ratio of the Female students (as % of total students) of New Zealand in 1976 to that in 1983?
Your answer should be compact. 0.93. What is the ratio of the Female students (as % of total students) in St. Vincent and the Grenadines in 1976 to that in 1983?
Ensure brevity in your answer.  0.91. What is the ratio of the Female students (as % of total students) of Togo in 1976 to that in 1983?
Offer a very short reply. 1.1. What is the ratio of the Female students (as % of total students) of Ecuador in 1976 to that in 1984?
Offer a terse response. 0.98. What is the ratio of the Female students (as % of total students) in New Zealand in 1976 to that in 1984?
Keep it short and to the point. 0.96. What is the ratio of the Female students (as % of total students) in St. Vincent and the Grenadines in 1976 to that in 1984?
Provide a succinct answer. 1.22. What is the ratio of the Female students (as % of total students) of Togo in 1976 to that in 1984?
Provide a short and direct response. 1.28. What is the ratio of the Female students (as % of total students) in Ecuador in 1976 to that in 1985?
Give a very brief answer. 1.07. What is the ratio of the Female students (as % of total students) in New Zealand in 1976 to that in 1985?
Provide a short and direct response. 0.94. What is the ratio of the Female students (as % of total students) of St. Vincent and the Grenadines in 1976 to that in 1985?
Offer a very short reply. 1.04. What is the ratio of the Female students (as % of total students) of Togo in 1976 to that in 1985?
Offer a terse response. 1.2. What is the ratio of the Female students (as % of total students) in Ecuador in 1976 to that in 1986?
Keep it short and to the point. 1.06. What is the ratio of the Female students (as % of total students) of New Zealand in 1976 to that in 1986?
Give a very brief answer. 0.98. What is the ratio of the Female students (as % of total students) in St. Vincent and the Grenadines in 1976 to that in 1986?
Ensure brevity in your answer.  0.9. What is the ratio of the Female students (as % of total students) in Togo in 1976 to that in 1986?
Your answer should be very brief. 1.13. What is the ratio of the Female students (as % of total students) in Ecuador in 1982 to that in 1983?
Keep it short and to the point. 1.02. What is the ratio of the Female students (as % of total students) of New Zealand in 1982 to that in 1983?
Offer a very short reply. 1.03. What is the ratio of the Female students (as % of total students) of St. Vincent and the Grenadines in 1982 to that in 1983?
Provide a short and direct response. 0.99. What is the ratio of the Female students (as % of total students) in Togo in 1982 to that in 1983?
Provide a succinct answer. 1.13. What is the ratio of the Female students (as % of total students) in New Zealand in 1982 to that in 1984?
Offer a very short reply. 1.07. What is the ratio of the Female students (as % of total students) in St. Vincent and the Grenadines in 1982 to that in 1984?
Your answer should be very brief. 1.33. What is the ratio of the Female students (as % of total students) in Togo in 1982 to that in 1984?
Offer a very short reply. 1.3. What is the ratio of the Female students (as % of total students) of Ecuador in 1982 to that in 1985?
Ensure brevity in your answer.  1.09. What is the ratio of the Female students (as % of total students) of New Zealand in 1982 to that in 1985?
Ensure brevity in your answer.  1.05. What is the ratio of the Female students (as % of total students) in St. Vincent and the Grenadines in 1982 to that in 1985?
Give a very brief answer. 1.14. What is the ratio of the Female students (as % of total students) of Togo in 1982 to that in 1985?
Offer a terse response. 1.23. What is the ratio of the Female students (as % of total students) in Ecuador in 1982 to that in 1986?
Your response must be concise. 1.09. What is the ratio of the Female students (as % of total students) of New Zealand in 1982 to that in 1986?
Ensure brevity in your answer.  1.09. What is the ratio of the Female students (as % of total students) of St. Vincent and the Grenadines in 1982 to that in 1986?
Ensure brevity in your answer.  0.98. What is the ratio of the Female students (as % of total students) of Togo in 1982 to that in 1986?
Your response must be concise. 1.16. What is the ratio of the Female students (as % of total students) of Ecuador in 1983 to that in 1984?
Offer a terse response. 0.99. What is the ratio of the Female students (as % of total students) of New Zealand in 1983 to that in 1984?
Give a very brief answer. 1.03. What is the ratio of the Female students (as % of total students) in St. Vincent and the Grenadines in 1983 to that in 1984?
Your answer should be compact. 1.34. What is the ratio of the Female students (as % of total students) in Togo in 1983 to that in 1984?
Your answer should be very brief. 1.16. What is the ratio of the Female students (as % of total students) of Ecuador in 1983 to that in 1985?
Your response must be concise. 1.08. What is the ratio of the Female students (as % of total students) in New Zealand in 1983 to that in 1985?
Your response must be concise. 1.02. What is the ratio of the Female students (as % of total students) of St. Vincent and the Grenadines in 1983 to that in 1985?
Keep it short and to the point. 1.15. What is the ratio of the Female students (as % of total students) of Togo in 1983 to that in 1985?
Give a very brief answer. 1.09. What is the ratio of the Female students (as % of total students) in Ecuador in 1983 to that in 1986?
Your answer should be very brief. 1.07. What is the ratio of the Female students (as % of total students) of New Zealand in 1983 to that in 1986?
Ensure brevity in your answer.  1.06. What is the ratio of the Female students (as % of total students) in St. Vincent and the Grenadines in 1983 to that in 1986?
Give a very brief answer. 0.99. What is the ratio of the Female students (as % of total students) in Togo in 1983 to that in 1986?
Your answer should be very brief. 1.03. What is the ratio of the Female students (as % of total students) in Ecuador in 1984 to that in 1985?
Your answer should be very brief. 1.09. What is the ratio of the Female students (as % of total students) of St. Vincent and the Grenadines in 1984 to that in 1985?
Your answer should be very brief. 0.86. What is the ratio of the Female students (as % of total students) in Togo in 1984 to that in 1985?
Your response must be concise. 0.94. What is the ratio of the Female students (as % of total students) of Ecuador in 1984 to that in 1986?
Make the answer very short. 1.08. What is the ratio of the Female students (as % of total students) in New Zealand in 1984 to that in 1986?
Provide a short and direct response. 1.02. What is the ratio of the Female students (as % of total students) of St. Vincent and the Grenadines in 1984 to that in 1986?
Your answer should be compact. 0.74. What is the ratio of the Female students (as % of total students) in Togo in 1984 to that in 1986?
Provide a succinct answer. 0.89. What is the ratio of the Female students (as % of total students) in New Zealand in 1985 to that in 1986?
Make the answer very short. 1.04. What is the ratio of the Female students (as % of total students) in St. Vincent and the Grenadines in 1985 to that in 1986?
Your answer should be very brief. 0.86. What is the ratio of the Female students (as % of total students) of Togo in 1985 to that in 1986?
Provide a succinct answer. 0.94. What is the difference between the highest and the second highest Female students (as % of total students) of Ecuador?
Provide a succinct answer. 0.35. What is the difference between the highest and the second highest Female students (as % of total students) in New Zealand?
Your answer should be compact. 2.8. What is the difference between the highest and the second highest Female students (as % of total students) of St. Vincent and the Grenadines?
Offer a terse response. 6.24. What is the difference between the highest and the second highest Female students (as % of total students) in Togo?
Your response must be concise. 0.66. What is the difference between the highest and the lowest Female students (as % of total students) in Ecuador?
Ensure brevity in your answer.  5.23. What is the difference between the highest and the lowest Female students (as % of total students) in New Zealand?
Offer a terse response. 8.82. What is the difference between the highest and the lowest Female students (as % of total students) of St. Vincent and the Grenadines?
Offer a terse response. 21.17. What is the difference between the highest and the lowest Female students (as % of total students) in Togo?
Offer a very short reply. 7.14. 